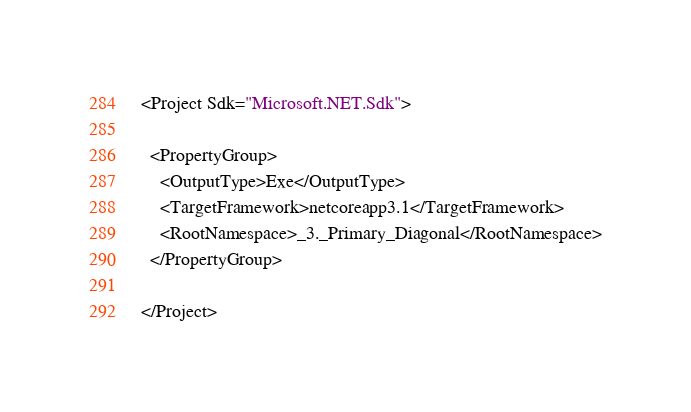Convert code to text. <code><loc_0><loc_0><loc_500><loc_500><_XML_><Project Sdk="Microsoft.NET.Sdk">

  <PropertyGroup>
    <OutputType>Exe</OutputType>
    <TargetFramework>netcoreapp3.1</TargetFramework>
    <RootNamespace>_3._Primary_Diagonal</RootNamespace>
  </PropertyGroup>

</Project>
</code> 